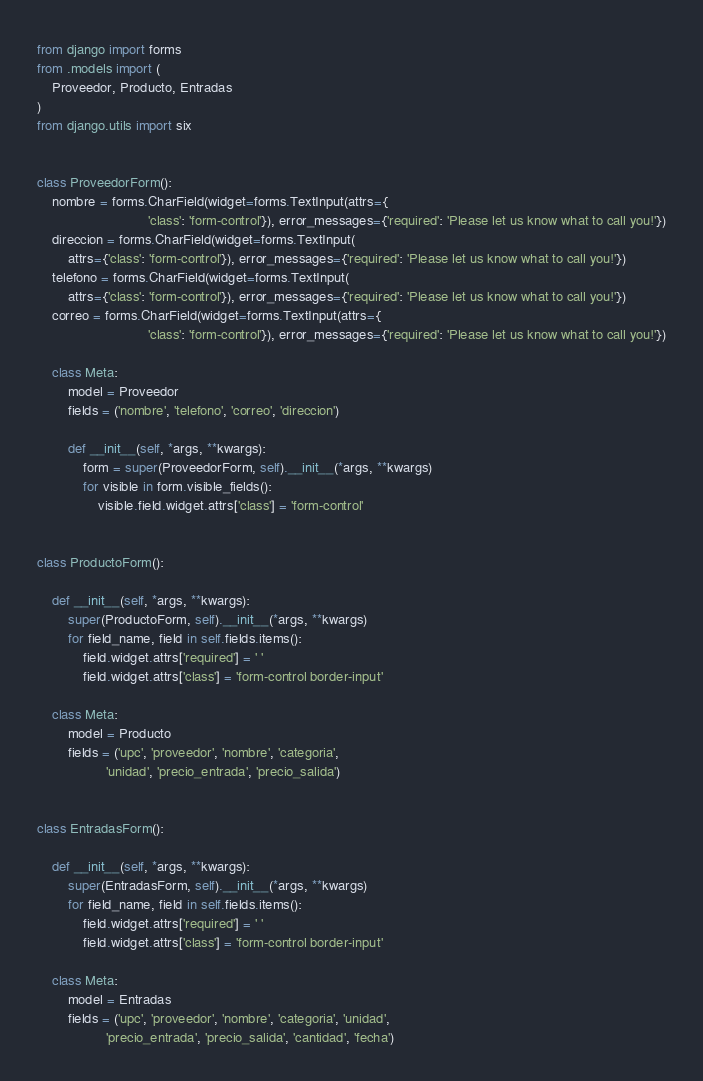<code> <loc_0><loc_0><loc_500><loc_500><_Python_>from django import forms
from .models import (
    Proveedor, Producto, Entradas
)
from django.utils import six


class ProveedorForm():
    nombre = forms.CharField(widget=forms.TextInput(attrs={
                             'class': 'form-control'}), error_messages={'required': 'Please let us know what to call you!'})
    direccion = forms.CharField(widget=forms.TextInput(
        attrs={'class': 'form-control'}), error_messages={'required': 'Please let us know what to call you!'})
    telefono = forms.CharField(widget=forms.TextInput(
        attrs={'class': 'form-control'}), error_messages={'required': 'Please let us know what to call you!'})
    correo = forms.CharField(widget=forms.TextInput(attrs={
                             'class': 'form-control'}), error_messages={'required': 'Please let us know what to call you!'})

    class Meta:
        model = Proveedor
        fields = ('nombre', 'telefono', 'correo', 'direccion')

        def __init__(self, *args, **kwargs):
            form = super(ProveedorForm, self).__init__(*args, **kwargs)
            for visible in form.visible_fields():
                visible.field.widget.attrs['class'] = 'form-control'


class ProductoForm():

    def __init__(self, *args, **kwargs):
        super(ProductoForm, self).__init__(*args, **kwargs)
        for field_name, field in self.fields.items():
            field.widget.attrs['required'] = ' '
            field.widget.attrs['class'] = 'form-control border-input'

    class Meta:
        model = Producto
        fields = ('upc', 'proveedor', 'nombre', 'categoria',
                  'unidad', 'precio_entrada', 'precio_salida')


class EntradasForm():

    def __init__(self, *args, **kwargs):
        super(EntradasForm, self).__init__(*args, **kwargs)
        for field_name, field in self.fields.items():
            field.widget.attrs['required'] = ' '
            field.widget.attrs['class'] = 'form-control border-input'

    class Meta:
        model = Entradas
        fields = ('upc', 'proveedor', 'nombre', 'categoria', 'unidad',
                  'precio_entrada', 'precio_salida', 'cantidad', 'fecha')
</code> 